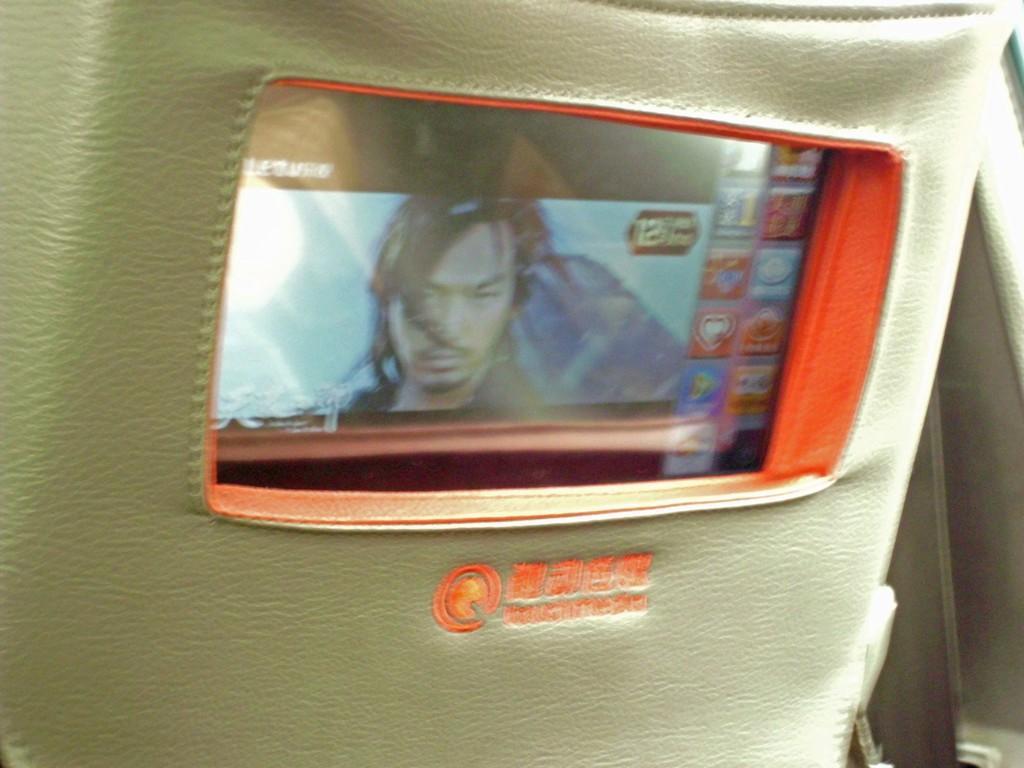How would you summarize this image in a sentence or two? In this image we can see an object looks like a vehicle seat and a screen attached to the seat. 